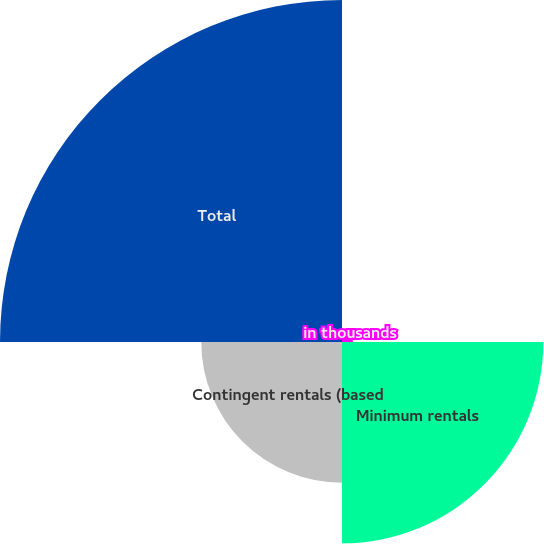<chart> <loc_0><loc_0><loc_500><loc_500><pie_chart><fcel>in thousands<fcel>Minimum rentals<fcel>Contingent rentals (based<fcel>Total<nl><fcel>1.57%<fcel>28.97%<fcel>20.25%<fcel>49.21%<nl></chart> 